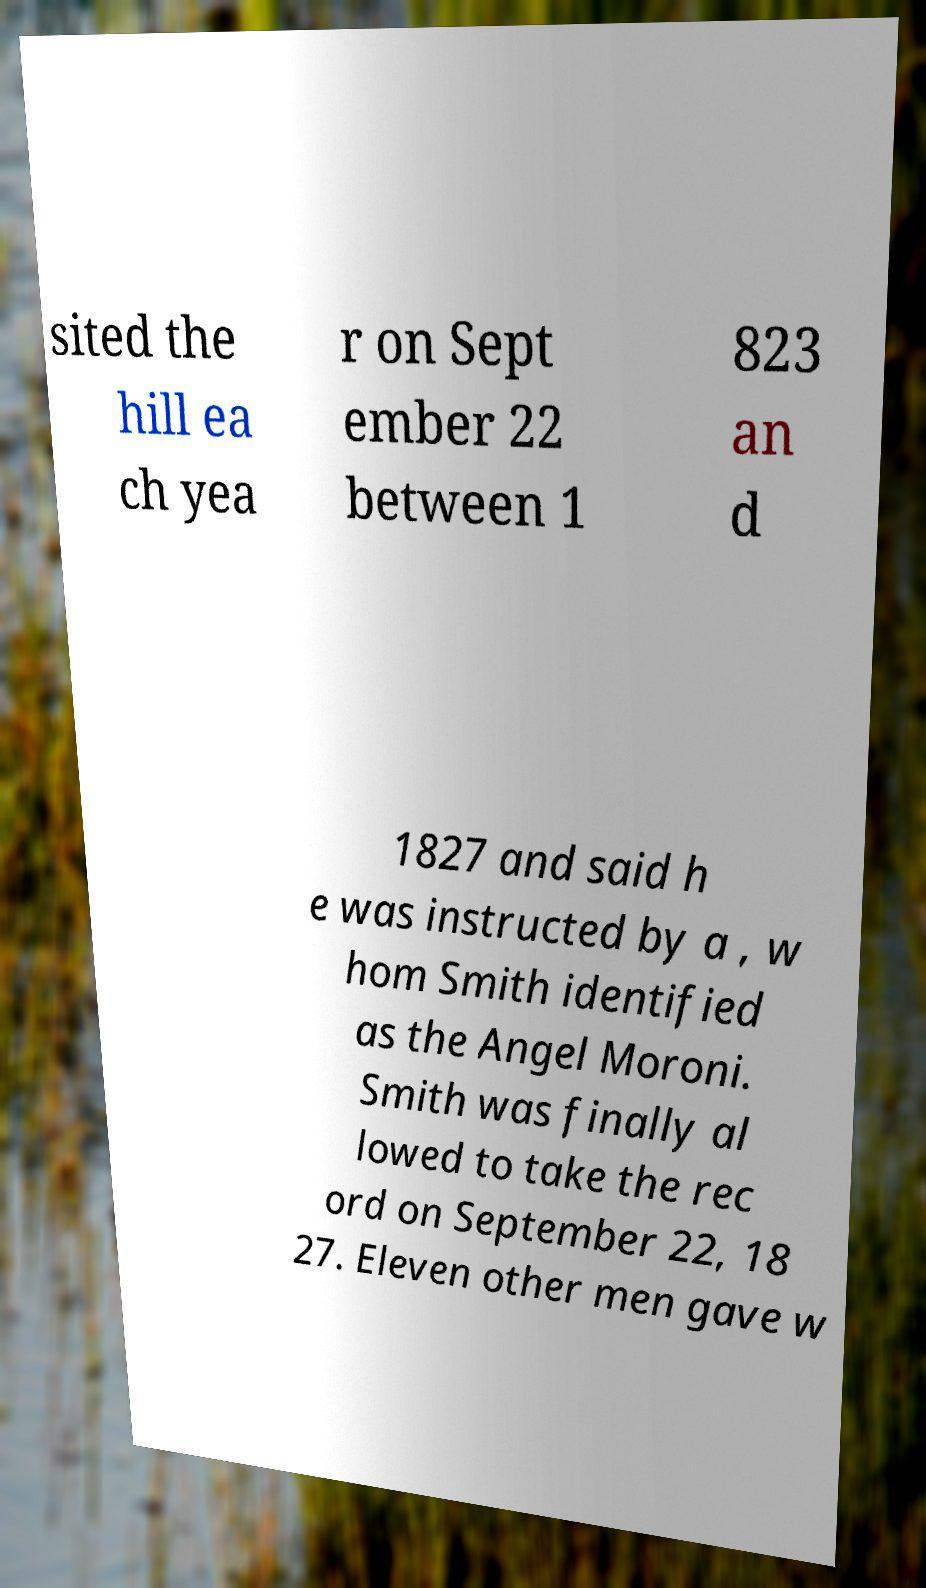Can you read and provide the text displayed in the image?This photo seems to have some interesting text. Can you extract and type it out for me? sited the hill ea ch yea r on Sept ember 22 between 1 823 an d 1827 and said h e was instructed by a , w hom Smith identified as the Angel Moroni. Smith was finally al lowed to take the rec ord on September 22, 18 27. Eleven other men gave w 